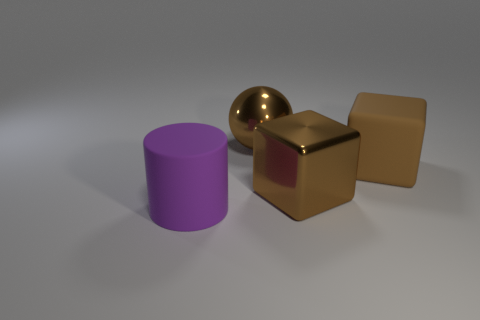Are there fewer purple rubber cylinders that are to the right of the brown sphere than large metallic cubes that are on the right side of the brown rubber cube?
Your response must be concise. No. What number of objects are either matte objects that are on the right side of the purple cylinder or big brown blocks?
Offer a very short reply. 2. There is a metal sphere; does it have the same size as the rubber thing that is behind the purple rubber object?
Make the answer very short. Yes. The metal object that is the same shape as the large brown matte thing is what size?
Offer a terse response. Large. There is a rubber object on the left side of the rubber object that is to the right of the cylinder; what number of big cubes are behind it?
Provide a succinct answer. 2. What number of cylinders are big gray matte things or purple matte objects?
Ensure brevity in your answer.  1. There is a rubber thing in front of the matte object behind the rubber thing that is to the left of the metal ball; what color is it?
Ensure brevity in your answer.  Purple. How many other things are there of the same size as the matte cylinder?
Provide a succinct answer. 3. Is there any other thing that is the same shape as the large purple matte thing?
Keep it short and to the point. No. What is the color of the shiny object that is the same shape as the large brown rubber thing?
Keep it short and to the point. Brown. 